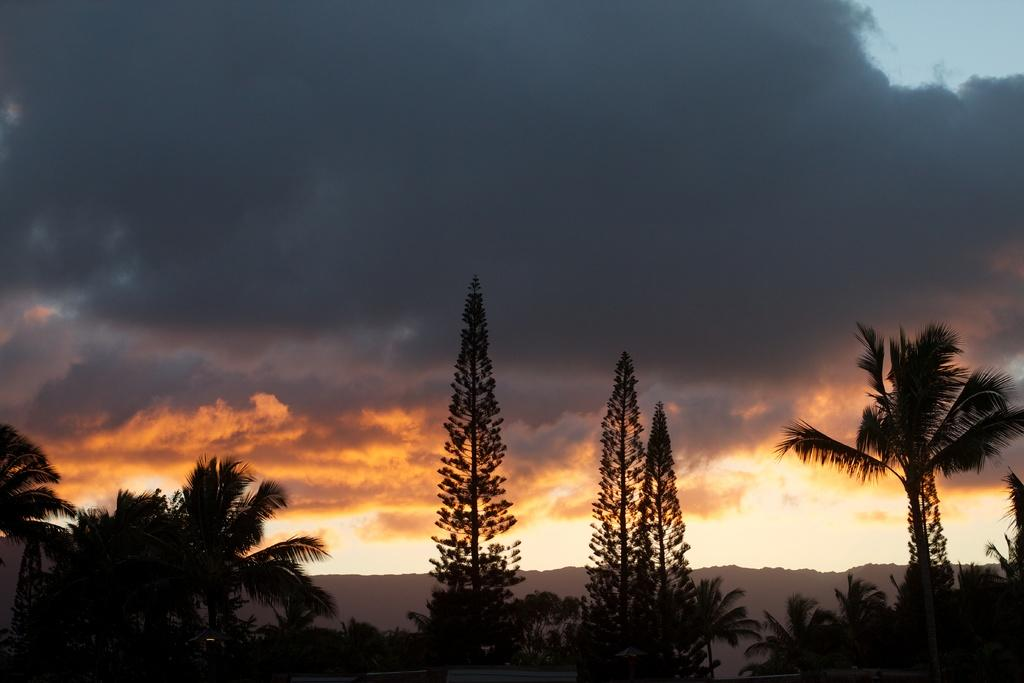What type of natural environment is depicted in the image? The image features many trees, suggesting a forest or wooded area. What can be seen in the distance behind the trees? There is a mountain visible in the background of the image. What is visible at the top of the image? The sky is visible at the top of the image. What can be observed in the sky? Clouds are present in the sky. How many friends are sitting on the berry in the image? There are no friends or berries present in the image. 